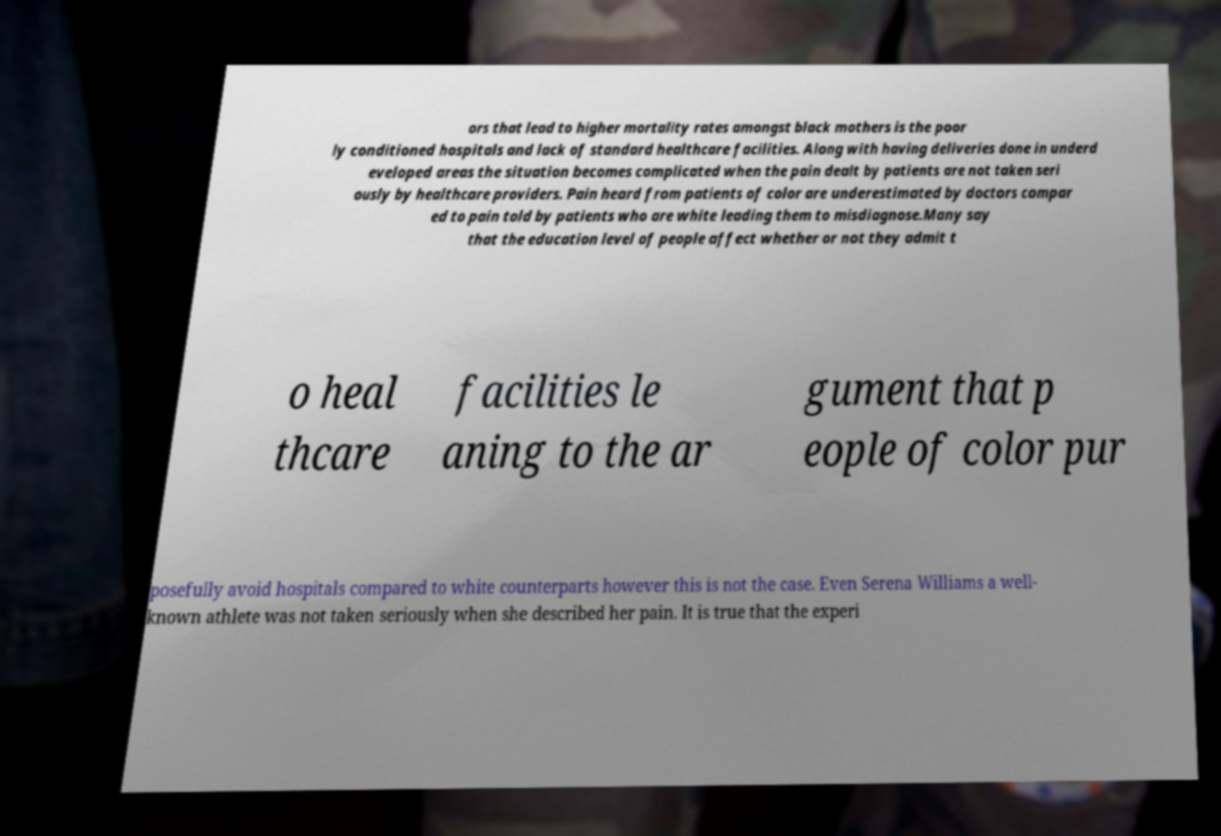What messages or text are displayed in this image? I need them in a readable, typed format. ors that lead to higher mortality rates amongst black mothers is the poor ly conditioned hospitals and lack of standard healthcare facilities. Along with having deliveries done in underd eveloped areas the situation becomes complicated when the pain dealt by patients are not taken seri ously by healthcare providers. Pain heard from patients of color are underestimated by doctors compar ed to pain told by patients who are white leading them to misdiagnose.Many say that the education level of people affect whether or not they admit t o heal thcare facilities le aning to the ar gument that p eople of color pur posefully avoid hospitals compared to white counterparts however this is not the case. Even Serena Williams a well- known athlete was not taken seriously when she described her pain. It is true that the experi 